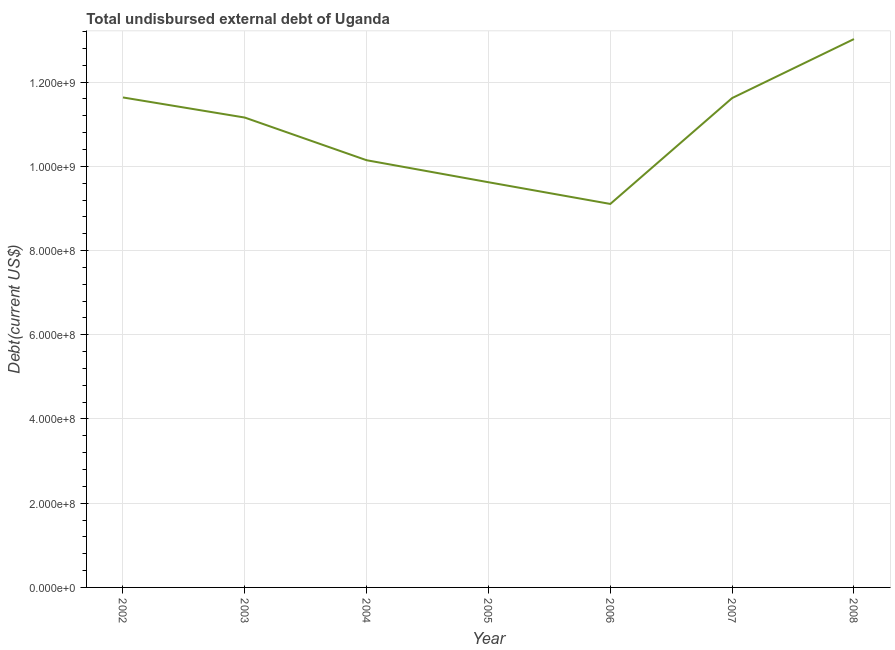What is the total debt in 2004?
Keep it short and to the point. 1.01e+09. Across all years, what is the maximum total debt?
Provide a short and direct response. 1.30e+09. Across all years, what is the minimum total debt?
Ensure brevity in your answer.  9.11e+08. In which year was the total debt minimum?
Provide a short and direct response. 2006. What is the sum of the total debt?
Give a very brief answer. 7.63e+09. What is the difference between the total debt in 2002 and 2008?
Your response must be concise. -1.39e+08. What is the average total debt per year?
Your answer should be compact. 1.09e+09. What is the median total debt?
Offer a terse response. 1.12e+09. In how many years, is the total debt greater than 600000000 US$?
Provide a succinct answer. 7. Do a majority of the years between 2006 and 2003 (inclusive) have total debt greater than 1200000000 US$?
Your answer should be very brief. Yes. What is the ratio of the total debt in 2002 to that in 2003?
Keep it short and to the point. 1.04. What is the difference between the highest and the second highest total debt?
Give a very brief answer. 1.39e+08. Is the sum of the total debt in 2002 and 2008 greater than the maximum total debt across all years?
Provide a short and direct response. Yes. What is the difference between the highest and the lowest total debt?
Your answer should be very brief. 3.92e+08. How many lines are there?
Provide a succinct answer. 1. What is the difference between two consecutive major ticks on the Y-axis?
Keep it short and to the point. 2.00e+08. Are the values on the major ticks of Y-axis written in scientific E-notation?
Offer a terse response. Yes. What is the title of the graph?
Your response must be concise. Total undisbursed external debt of Uganda. What is the label or title of the Y-axis?
Provide a succinct answer. Debt(current US$). What is the Debt(current US$) of 2002?
Provide a succinct answer. 1.16e+09. What is the Debt(current US$) in 2003?
Your response must be concise. 1.12e+09. What is the Debt(current US$) of 2004?
Your response must be concise. 1.01e+09. What is the Debt(current US$) of 2005?
Keep it short and to the point. 9.62e+08. What is the Debt(current US$) of 2006?
Give a very brief answer. 9.11e+08. What is the Debt(current US$) in 2007?
Your answer should be compact. 1.16e+09. What is the Debt(current US$) of 2008?
Your answer should be very brief. 1.30e+09. What is the difference between the Debt(current US$) in 2002 and 2003?
Make the answer very short. 4.78e+07. What is the difference between the Debt(current US$) in 2002 and 2004?
Your response must be concise. 1.49e+08. What is the difference between the Debt(current US$) in 2002 and 2005?
Keep it short and to the point. 2.01e+08. What is the difference between the Debt(current US$) in 2002 and 2006?
Make the answer very short. 2.53e+08. What is the difference between the Debt(current US$) in 2002 and 2007?
Your response must be concise. 1.46e+06. What is the difference between the Debt(current US$) in 2002 and 2008?
Give a very brief answer. -1.39e+08. What is the difference between the Debt(current US$) in 2003 and 2004?
Provide a succinct answer. 1.01e+08. What is the difference between the Debt(current US$) in 2003 and 2005?
Ensure brevity in your answer.  1.54e+08. What is the difference between the Debt(current US$) in 2003 and 2006?
Your answer should be compact. 2.05e+08. What is the difference between the Debt(current US$) in 2003 and 2007?
Your answer should be compact. -4.63e+07. What is the difference between the Debt(current US$) in 2003 and 2008?
Your answer should be very brief. -1.86e+08. What is the difference between the Debt(current US$) in 2004 and 2005?
Provide a short and direct response. 5.23e+07. What is the difference between the Debt(current US$) in 2004 and 2006?
Give a very brief answer. 1.04e+08. What is the difference between the Debt(current US$) in 2004 and 2007?
Offer a very short reply. -1.48e+08. What is the difference between the Debt(current US$) in 2004 and 2008?
Provide a succinct answer. -2.88e+08. What is the difference between the Debt(current US$) in 2005 and 2006?
Offer a terse response. 5.15e+07. What is the difference between the Debt(current US$) in 2005 and 2007?
Make the answer very short. -2.00e+08. What is the difference between the Debt(current US$) in 2005 and 2008?
Give a very brief answer. -3.40e+08. What is the difference between the Debt(current US$) in 2006 and 2007?
Offer a terse response. -2.51e+08. What is the difference between the Debt(current US$) in 2006 and 2008?
Offer a very short reply. -3.92e+08. What is the difference between the Debt(current US$) in 2007 and 2008?
Ensure brevity in your answer.  -1.40e+08. What is the ratio of the Debt(current US$) in 2002 to that in 2003?
Your response must be concise. 1.04. What is the ratio of the Debt(current US$) in 2002 to that in 2004?
Provide a short and direct response. 1.15. What is the ratio of the Debt(current US$) in 2002 to that in 2005?
Keep it short and to the point. 1.21. What is the ratio of the Debt(current US$) in 2002 to that in 2006?
Your response must be concise. 1.28. What is the ratio of the Debt(current US$) in 2002 to that in 2008?
Provide a short and direct response. 0.89. What is the ratio of the Debt(current US$) in 2003 to that in 2005?
Provide a succinct answer. 1.16. What is the ratio of the Debt(current US$) in 2003 to that in 2006?
Offer a terse response. 1.23. What is the ratio of the Debt(current US$) in 2003 to that in 2007?
Give a very brief answer. 0.96. What is the ratio of the Debt(current US$) in 2003 to that in 2008?
Provide a succinct answer. 0.86. What is the ratio of the Debt(current US$) in 2004 to that in 2005?
Make the answer very short. 1.05. What is the ratio of the Debt(current US$) in 2004 to that in 2006?
Offer a terse response. 1.11. What is the ratio of the Debt(current US$) in 2004 to that in 2007?
Keep it short and to the point. 0.87. What is the ratio of the Debt(current US$) in 2004 to that in 2008?
Give a very brief answer. 0.78. What is the ratio of the Debt(current US$) in 2005 to that in 2006?
Your answer should be very brief. 1.06. What is the ratio of the Debt(current US$) in 2005 to that in 2007?
Your answer should be very brief. 0.83. What is the ratio of the Debt(current US$) in 2005 to that in 2008?
Ensure brevity in your answer.  0.74. What is the ratio of the Debt(current US$) in 2006 to that in 2007?
Provide a short and direct response. 0.78. What is the ratio of the Debt(current US$) in 2006 to that in 2008?
Provide a succinct answer. 0.7. What is the ratio of the Debt(current US$) in 2007 to that in 2008?
Provide a short and direct response. 0.89. 